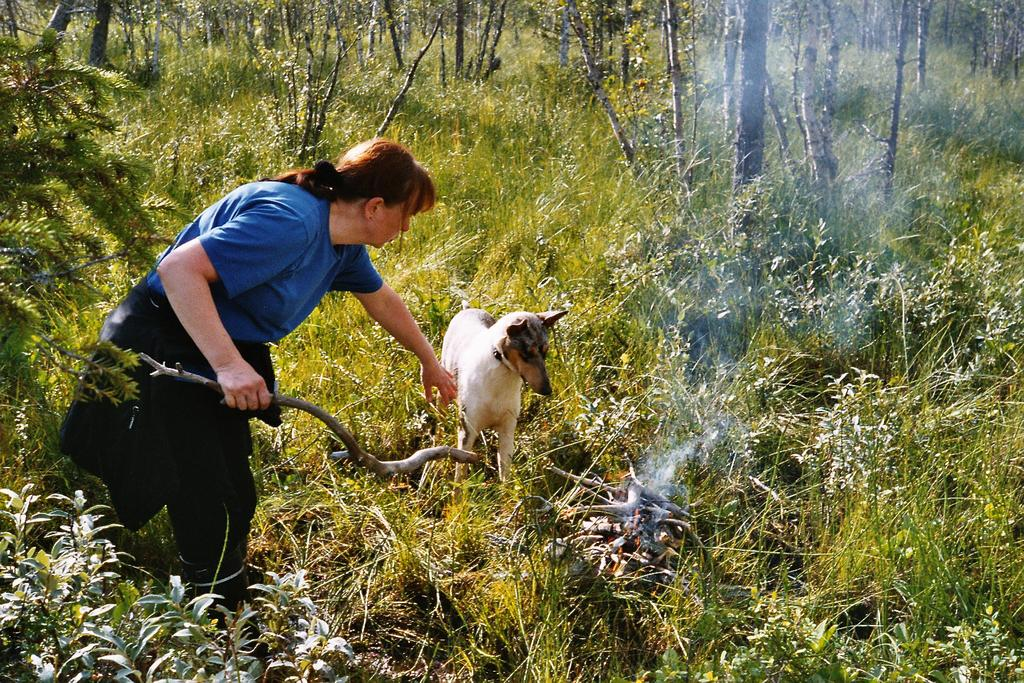Who is present in the image? There is a lady in the image. What is the lady holding in the image? The lady is holding a stick. What other living creature is in the image? There is a dog in the image. What type of terrain is visible at the bottom of the image? Grass and plants are present at the bottom of the image. What can be seen in the background of the image? There are trees in the background of the image. What type of chess piece is the lady holding in the image? The lady is not holding a chess piece in the image; she is holding a stick. Is there a parcel being delivered in the image? There is no mention of a parcel in the image; it features a lady, a dog, and a stick. 